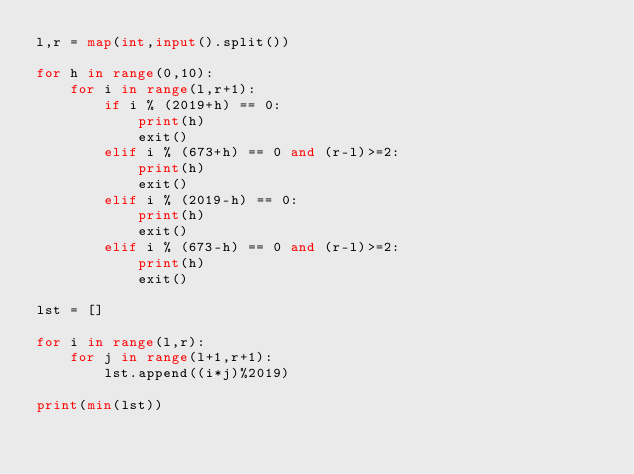Convert code to text. <code><loc_0><loc_0><loc_500><loc_500><_Python_>l,r = map(int,input().split())

for h in range(0,10):
	for i in range(l,r+1):
		if i % (2019+h) == 0:
			print(h)
			exit()
		elif i % (673+h) == 0 and (r-l)>=2:
			print(h)
			exit()
		elif i % (2019-h) == 0:
			print(h)
			exit()
		elif i % (673-h) == 0 and (r-l)>=2:
			print(h)
			exit()
			
lst = []

for i in range(l,r):
	for j in range(l+1,r+1):
		lst.append((i*j)%2019)

print(min(lst))
</code> 